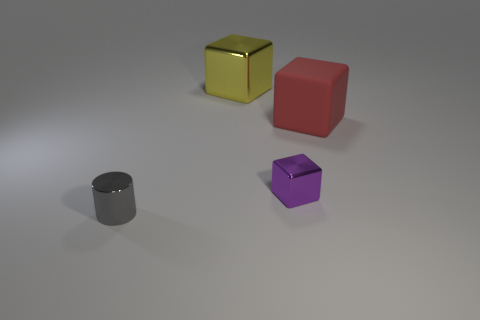Is the shape of the tiny gray thing the same as the red matte thing? No, the shapes are different. The tiny gray object appears to be cylindrical, whereas the red object has a cube-like shape with a matte finish. 